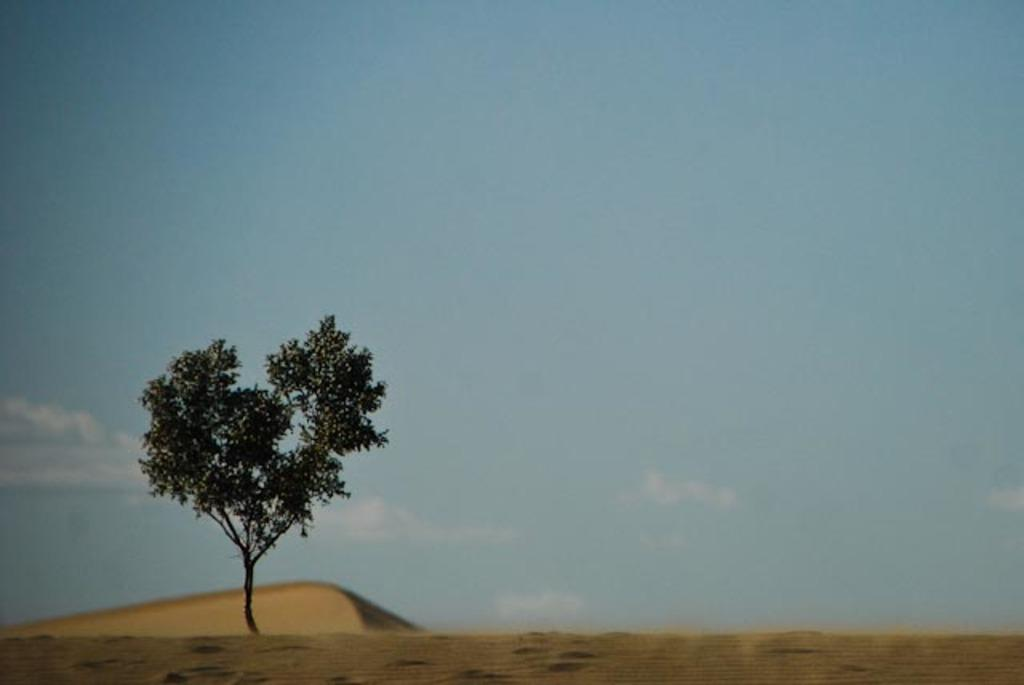What type of ground surface is visible at the bottom of the image? There is sand on the ground at the bottom of the image. What natural element can be seen in the image? There is a tree in the image. What is visible in the background of the image? The sky is visible in the background of the image. Who is the representative of the beggar community in the image? There is no representative of the beggar community present in the image. 